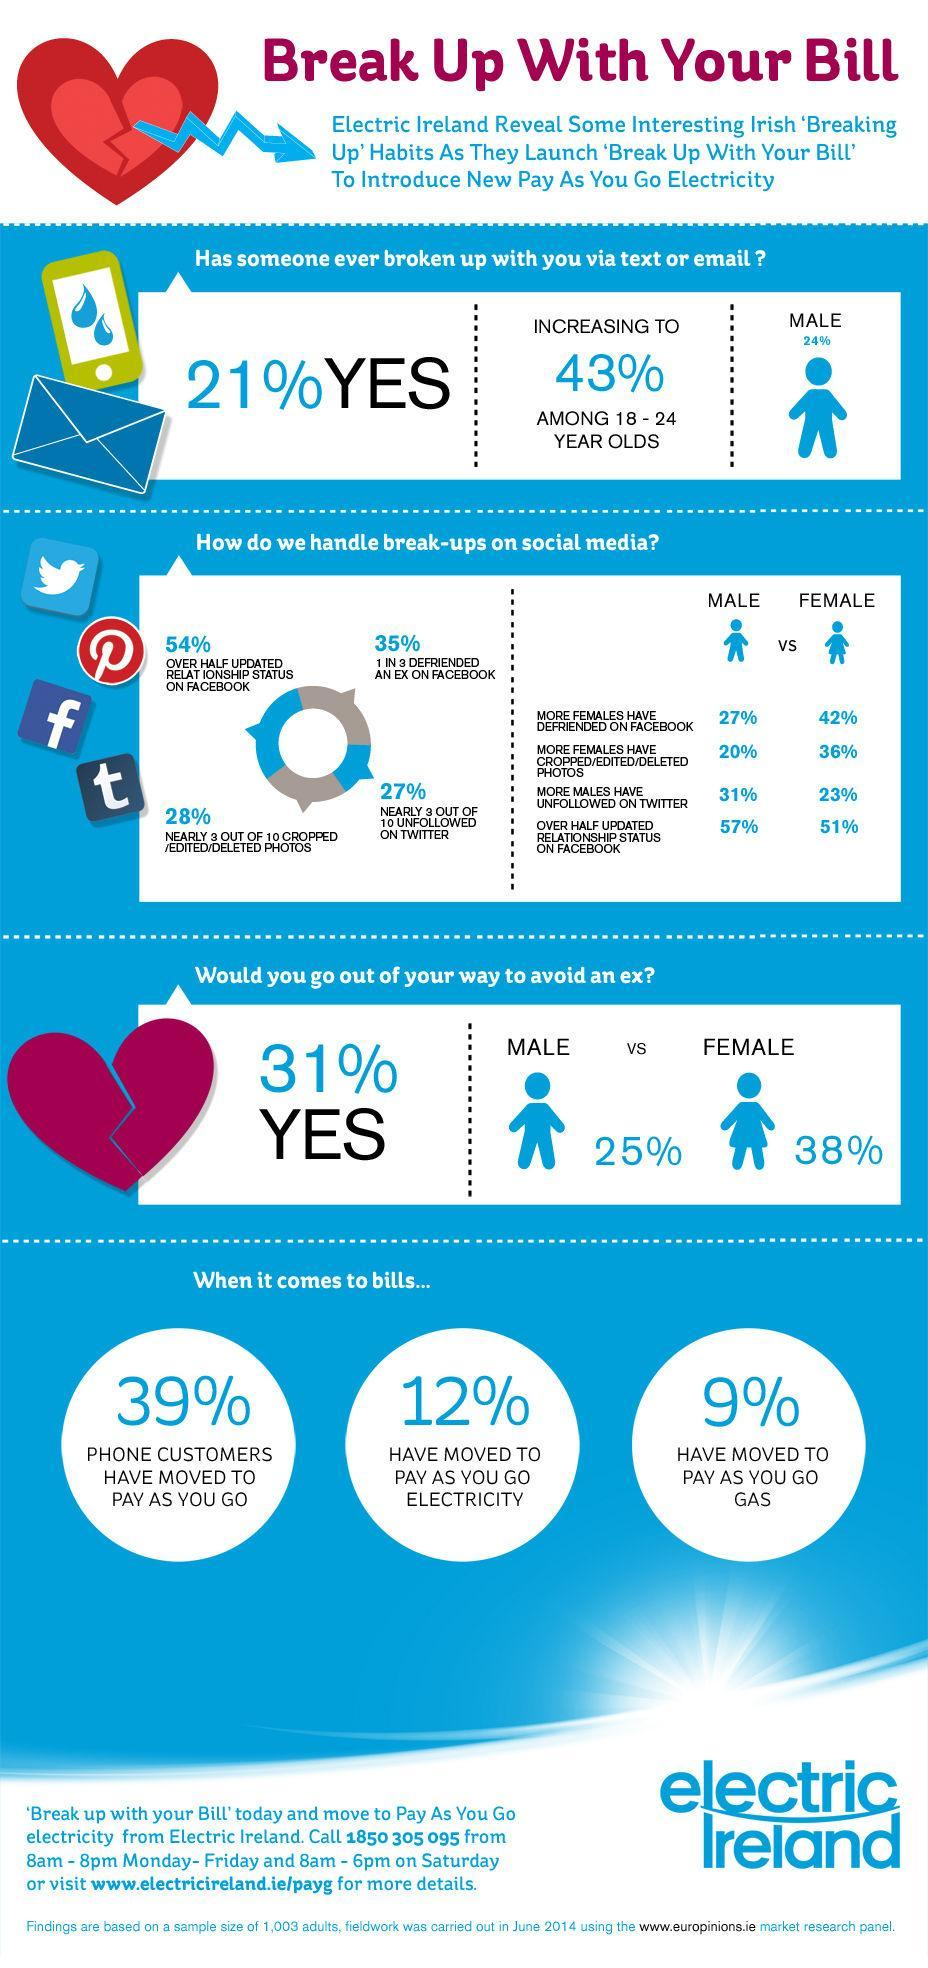Out of 10, how many people continue to follow on Twitter even after break-ups?
Answer the question with a short phrase. 7 What percentage of people cropped/deleted/edited photos on social media after the break-up? 28% What percentage have moved to pay as you go gas? 9% Which gender goes out more to avoid ex-male, female? female What percentage of people continue to follow on Twitter even after break-ups? 73% What percentage of people with half updated relationship status on Facebook? 54% 